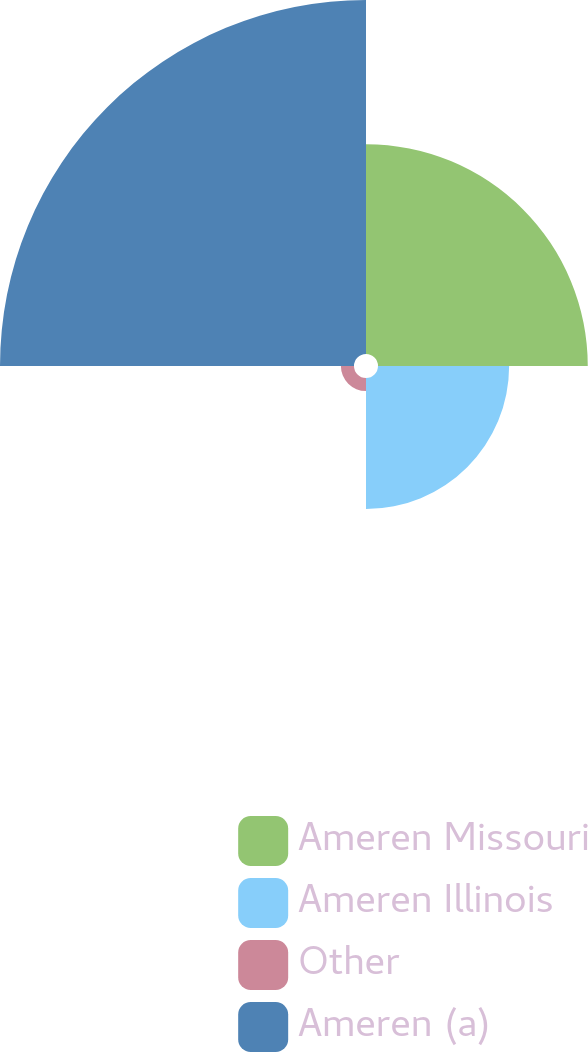<chart> <loc_0><loc_0><loc_500><loc_500><pie_chart><fcel>Ameren Missouri<fcel>Ameren Illinois<fcel>Other<fcel>Ameren (a)<nl><fcel>29.63%<fcel>18.52%<fcel>1.85%<fcel>50.0%<nl></chart> 